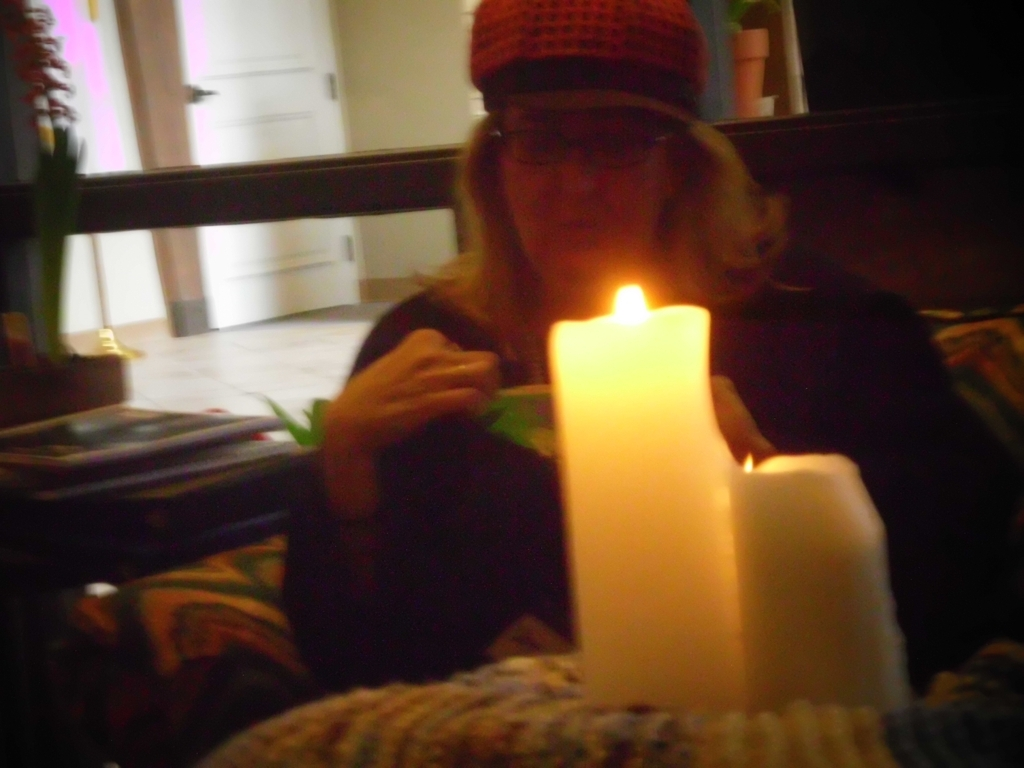What mood does the lighting in this image evoke? The soft, focused light from the candle gives the image a calm and intimate feel, evoking a sense of tranquility and perhaps reflection or meditation. The low light and shadows could also contribute to a feeling of solitude or quietude. 